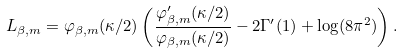<formula> <loc_0><loc_0><loc_500><loc_500>L _ { \beta , m } = \varphi _ { \beta , m } ( \kappa / 2 ) \left ( \frac { \varphi ^ { \prime } _ { \beta , m } ( \kappa / 2 ) } { \varphi _ { \beta , m } ( \kappa / 2 ) } - 2 \Gamma ^ { \prime } ( 1 ) + \log ( 8 \pi ^ { 2 } ) \right ) .</formula> 